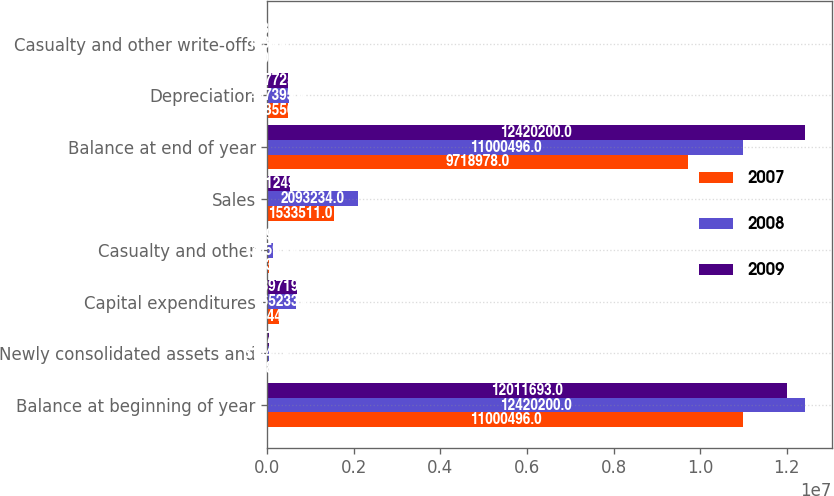Convert chart. <chart><loc_0><loc_0><loc_500><loc_500><stacked_bar_chart><ecel><fcel>Balance at beginning of year<fcel>Newly consolidated assets and<fcel>Capital expenditures<fcel>Casualty and other<fcel>Sales<fcel>Balance at end of year<fcel>Depreciation<fcel>Casualty and other write-offs<nl><fcel>2007<fcel>1.10005e+07<fcel>19683<fcel>275444<fcel>43134<fcel>1.53351e+06<fcel>9.71898e+06<fcel>478550<fcel>5200<nl><fcel>2008<fcel>1.24202e+07<fcel>31447<fcel>665233<fcel>130595<fcel>2.09323e+06<fcel>1.10005e+07<fcel>497395<fcel>1838<nl><fcel>2009<fcel>1.20117e+07<fcel>31572<fcel>689719<fcel>24594<fcel>521249<fcel>1.24202e+07<fcel>477725<fcel>5280<nl></chart> 